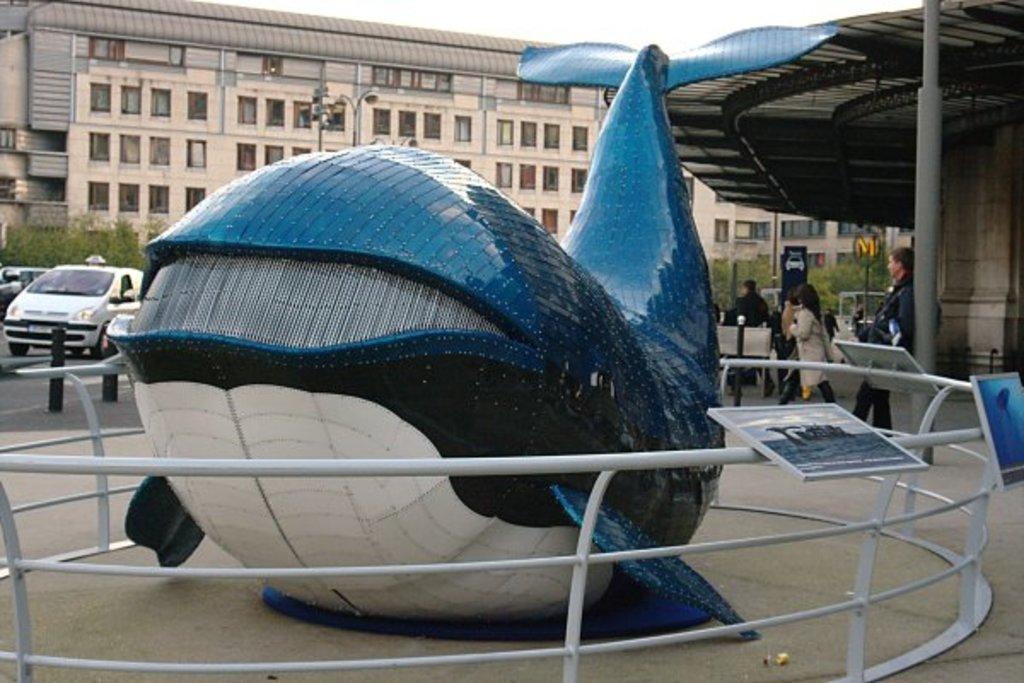Could you give a brief overview of what you see in this image? In this picture we can see vehicles,people on the ground and in the background we can see buildings,sky. 